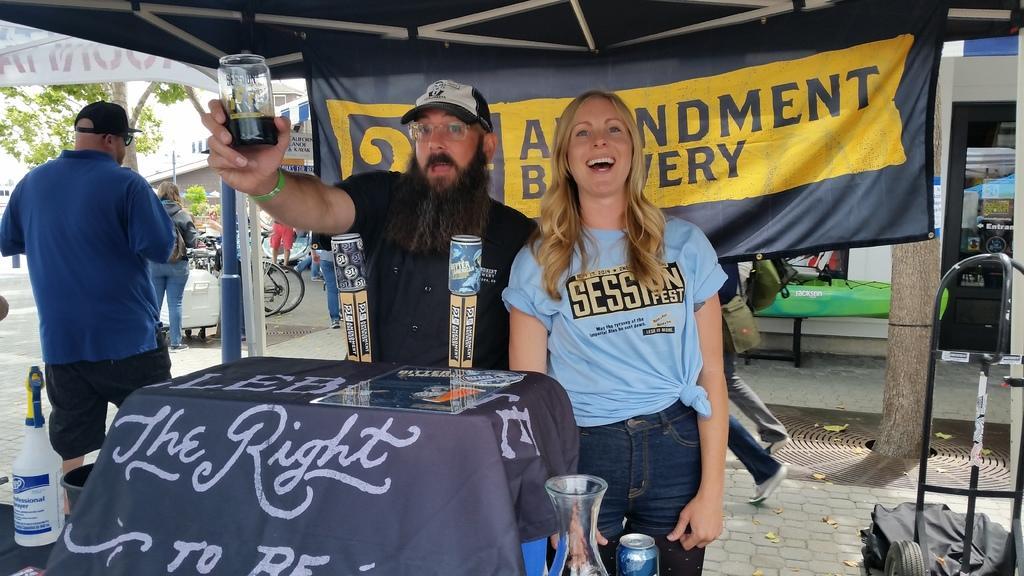In one or two sentences, can you explain what this image depicts? The image is taken in the streets. In the center of the image there are two people standing. the man who is wearing a black shirt is holding a jar in his hand before him there is a table and we can see jar, tins, bottles which are placed on the table. In the background there are people standing. we can see a board and a tent. On the left there is a tree and some bicycles. 